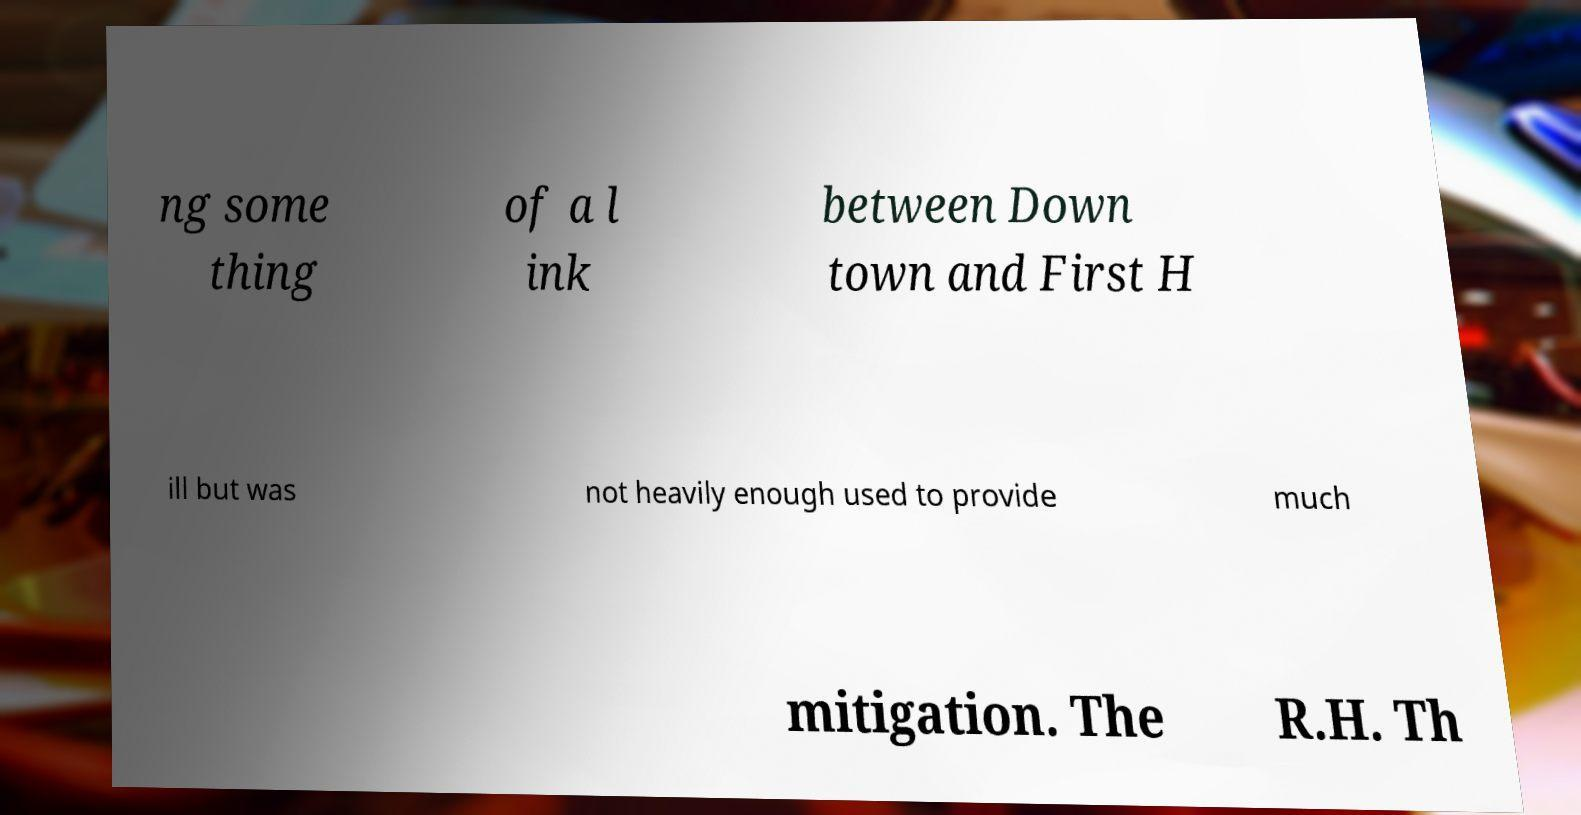I need the written content from this picture converted into text. Can you do that? ng some thing of a l ink between Down town and First H ill but was not heavily enough used to provide much mitigation. The R.H. Th 